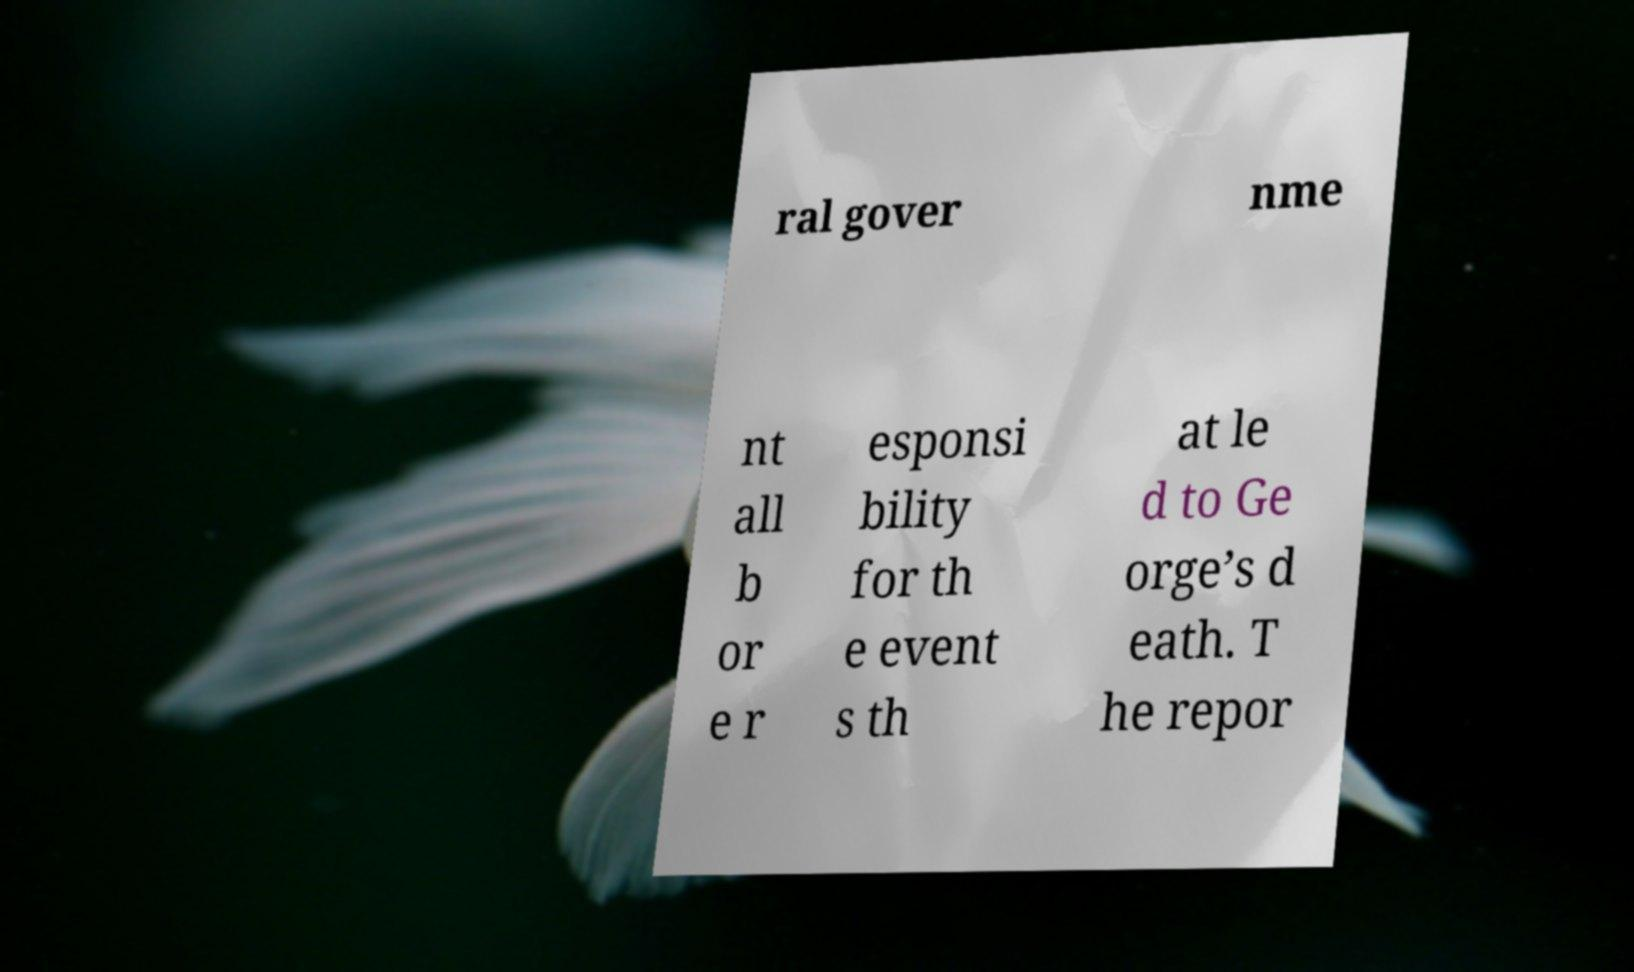Please read and relay the text visible in this image. What does it say? ral gover nme nt all b or e r esponsi bility for th e event s th at le d to Ge orge’s d eath. T he repor 